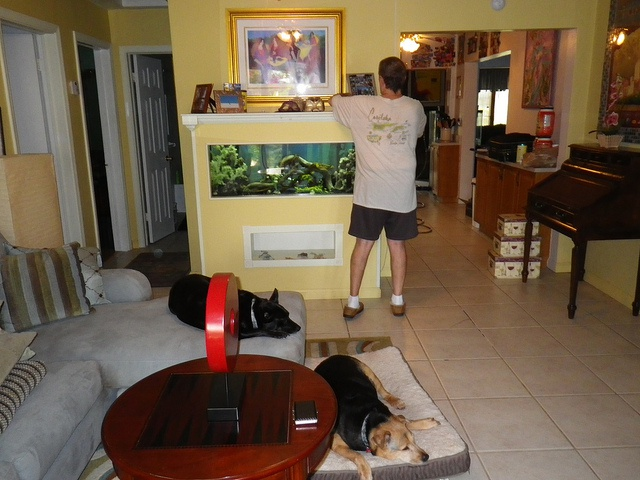Describe the objects in this image and their specific colors. I can see couch in olive, gray, and black tones, people in olive, darkgray, black, tan, and gray tones, couch in olive and gray tones, dog in olive, black, gray, tan, and darkgray tones, and bed in olive, darkgray, and gray tones in this image. 